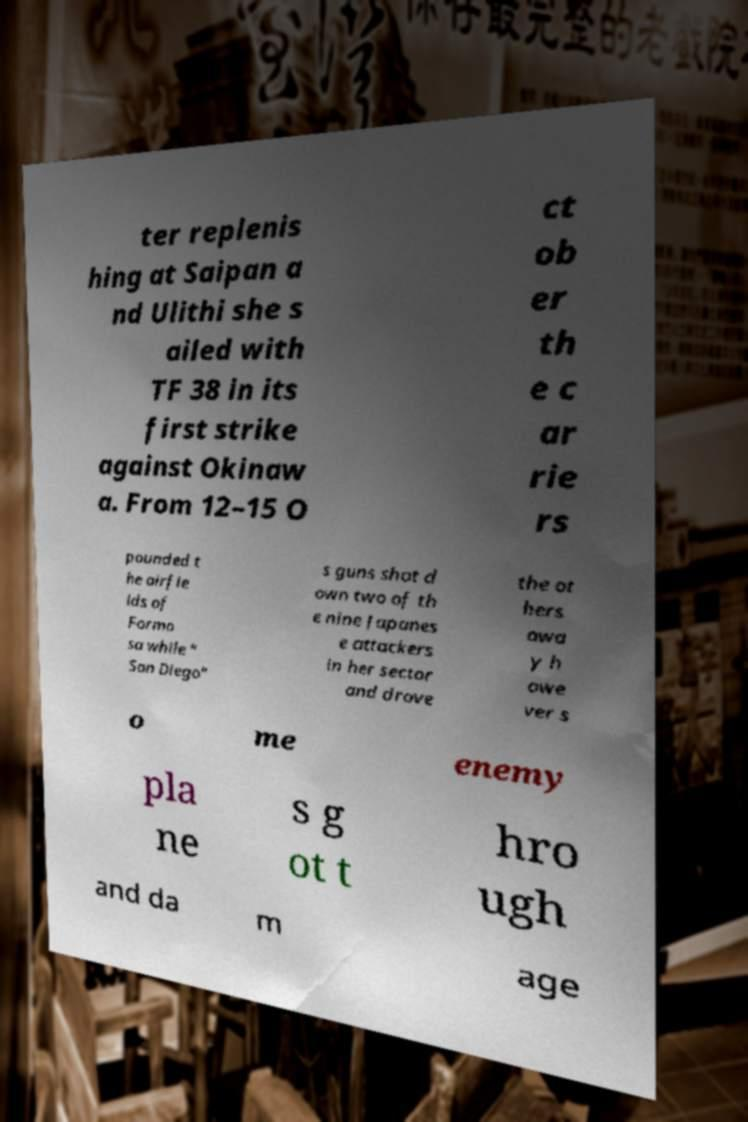Can you read and provide the text displayed in the image?This photo seems to have some interesting text. Can you extract and type it out for me? ter replenis hing at Saipan a nd Ulithi she s ailed with TF 38 in its first strike against Okinaw a. From 12–15 O ct ob er th e c ar rie rs pounded t he airfie lds of Formo sa while " San Diego" s guns shot d own two of th e nine Japanes e attackers in her sector and drove the ot hers awa y h owe ver s o me enemy pla ne s g ot t hro ugh and da m age 